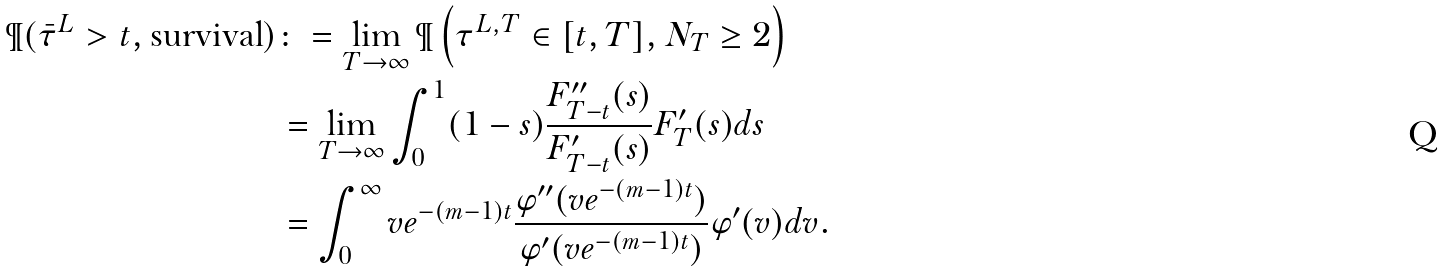<formula> <loc_0><loc_0><loc_500><loc_500>\P ( \bar { \tau } ^ { L } > t , \text {survival} ) & \colon = \lim _ { T \to \infty } \P \left ( \tau ^ { L , T } \in [ t , T ] , N _ { T } \geq 2 \right ) \\ & = \lim _ { T \to \infty } \int _ { 0 } ^ { 1 } ( 1 - s ) \frac { F ^ { \prime \prime } _ { T - t } ( s ) } { F ^ { \prime } _ { T - t } ( s ) } F ^ { \prime } _ { T } ( s ) d s \\ & = \int _ { 0 } ^ { \infty } v e ^ { - ( m - 1 ) t } \frac { \varphi ^ { \prime \prime } ( v e ^ { - ( m - 1 ) t } ) } { \varphi ^ { \prime } ( v e ^ { - ( m - 1 ) t } ) } \varphi ^ { \prime } ( v ) d v .</formula> 